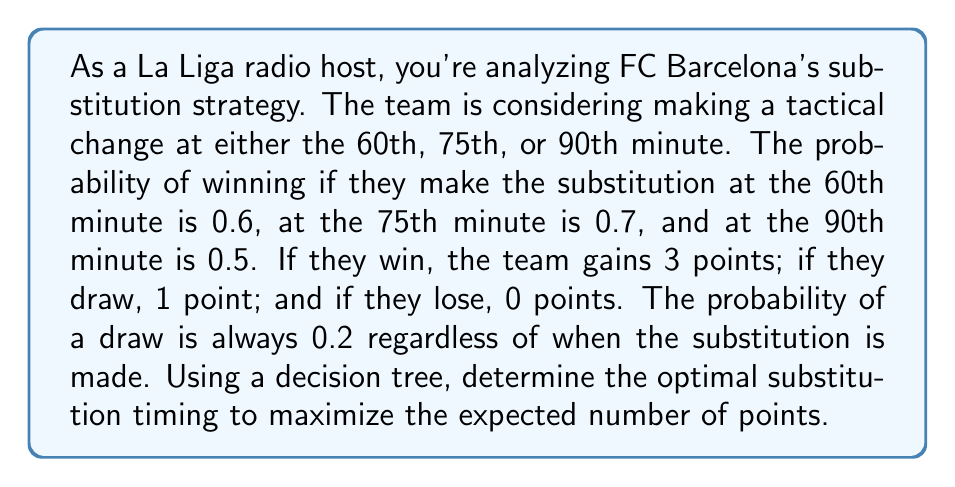Provide a solution to this math problem. Let's approach this step-by-step using a decision tree:

1) First, let's calculate the probability of losing for each substitution time:
   - 60th minute: $P(\text{lose}) = 1 - P(\text{win}) - P(\text{draw}) = 1 - 0.6 - 0.2 = 0.2$
   - 75th minute: $P(\text{lose}) = 1 - 0.7 - 0.2 = 0.1$
   - 90th minute: $P(\text{lose}) = 1 - 0.5 - 0.2 = 0.3$

2) Now, let's calculate the expected points for each substitution time:

   60th minute:
   $$E(\text{points}) = 3 \cdot 0.6 + 1 \cdot 0.2 + 0 \cdot 0.2 = 2.0$$

   75th minute:
   $$E(\text{points}) = 3 \cdot 0.7 + 1 \cdot 0.2 + 0 \cdot 0.1 = 2.3$$

   90th minute:
   $$E(\text{points}) = 3 \cdot 0.5 + 1 \cdot 0.2 + 0 \cdot 0.3 = 1.7$$

3) The decision tree would look like this:

   [asy]
   import geometry;

   size(200,150);

   pair A = (0,0);
   pair B1 = (100,50);
   pair B2 = (100,0);
   pair B3 = (100,-50);

   draw(A--B1);
   draw(A--B2);
   draw(A--B3);

   label("Start", A, W);
   label("60th (2.0)", B1, E);
   label("75th (2.3)", B2, E);
   label("90th (1.7)", B3, E);
   [/asy]

4) From the decision tree, we can see that the highest expected points (2.3) comes from making the substitution at the 75th minute.
Answer: The optimal substitution timing is at the 75th minute, which yields an expected 2.3 points. 